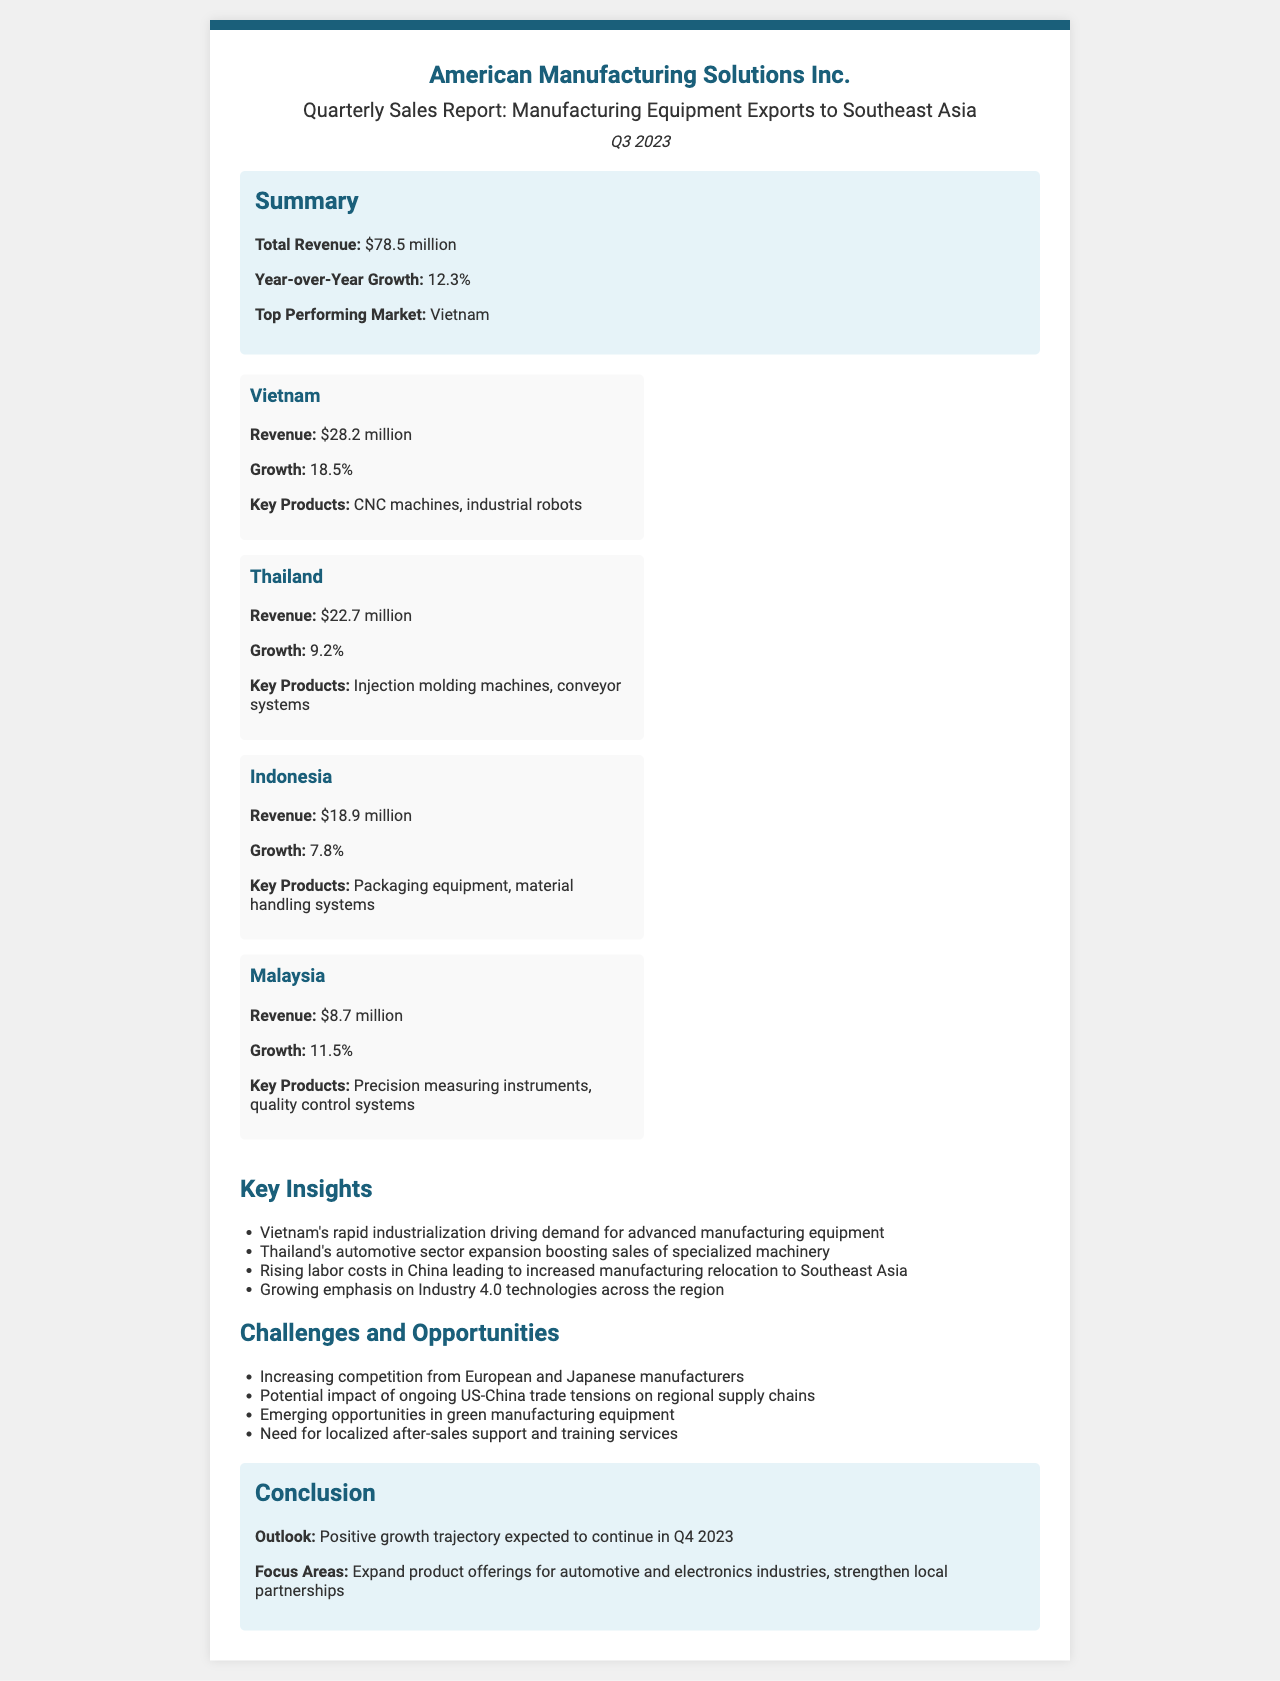what is the total revenue? The total revenue for manufacturing equipment exports to Southeast Asia during Q3 2023 is stated in the summary section of the document.
Answer: $78.5 million which market had the highest revenue? The market with the highest revenue is identified in the summary of the document, specifically mentioning Vietnam.
Answer: Vietnam what is the year-over-year growth percentage? The year-over-year growth is clearly specified in the summary section of the report.
Answer: 12.3% which country has the lowest revenue in this report? The revenue breakdown shows that Malaysia has the lowest revenue among the listed countries.
Answer: Malaysia what are the key products for Thailand? The key products for Thailand are listed under the respective market breakdown.
Answer: Injection molding machines, conveyor systems what challenge is mentioned regarding competition? The challenges section outlines various obstacles, including competition from other manufacturers.
Answer: Increasing competition from European and Japanese manufacturers what is the expected outlook for Q4 2023? The conclusion provides an optimistic forecast regarding future growth in the upcoming quarter.
Answer: Positive growth trajectory expected which country experienced the highest growth percentage? The growth percentages for each market indicate that Vietnam has the highest growth rate.
Answer: 18.5% what is a focus area for future expansion? The conclusion suggests certain strategic focus areas for the company's growth in the following period.
Answer: Expand product offerings for automotive and electronics industries, strengthen local partnerships 